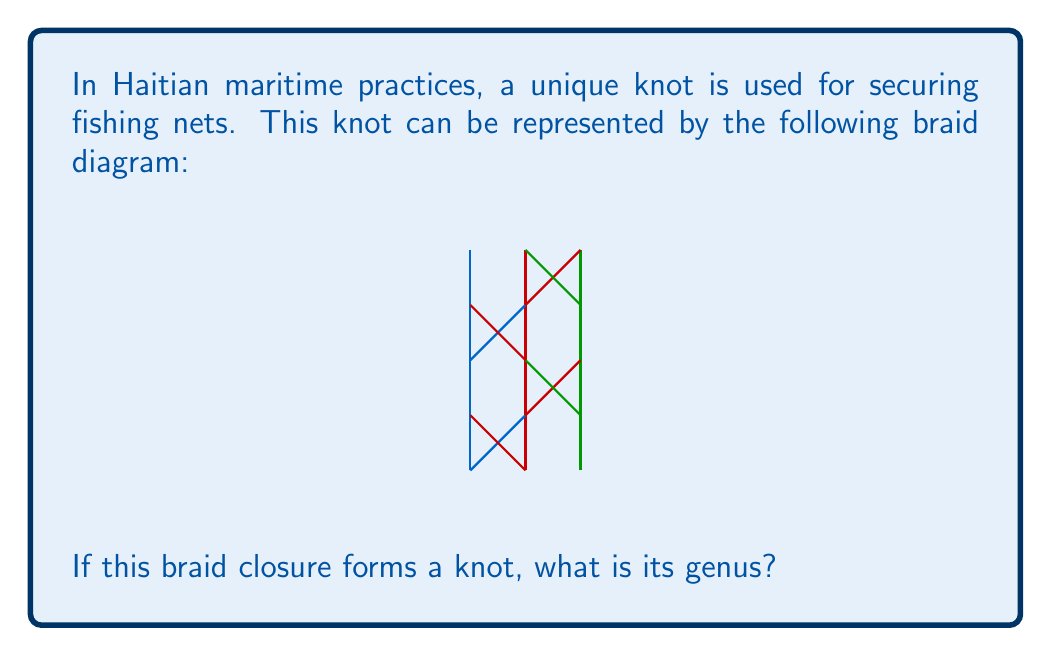Give your solution to this math problem. To determine the genus of the knot formed by the given braid closure, we'll follow these steps:

1) First, we need to identify the braid word. From the diagram, we can see that the braid word is $\sigma_1 \sigma_2 \sigma_1 \sigma_2$, where $\sigma_i$ represents a positive crossing of the $i$-th and $(i+1)$-th strands.

2) The braid index $n$ is 3, as there are 3 strands in the braid.

3) To find the genus, we'll use the formula:

   $$g = \frac{1}{2}(1 - n + e)$$

   where $g$ is the genus, $n$ is the number of components in the link, and $e$ is the exponent sum of the braid word.

4) In this case, the braid closure forms a knot, so $n = 1$.

5) The exponent sum $e$ is the number of positive crossings minus the number of negative crossings. In this braid word, all crossings are positive, so $e = 4$.

6) Plugging these values into the formula:

   $$g = \frac{1}{2}(1 - 1 + 4) = \frac{1}{2}(4) = 2$$

Therefore, the genus of the knot is 2.
Answer: 2 